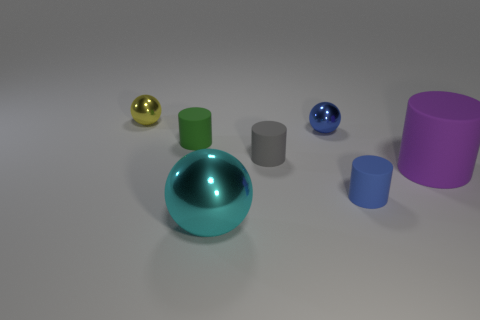Are there an equal number of tiny cylinders that are on the left side of the blue rubber cylinder and tiny purple shiny balls? Upon reviewing the image, there are two tiny cylinders on the left side of the blue rubber cylinder, contrasted with one tiny purple shiny ball opposite to them. Therefore, they are not equal in number. 